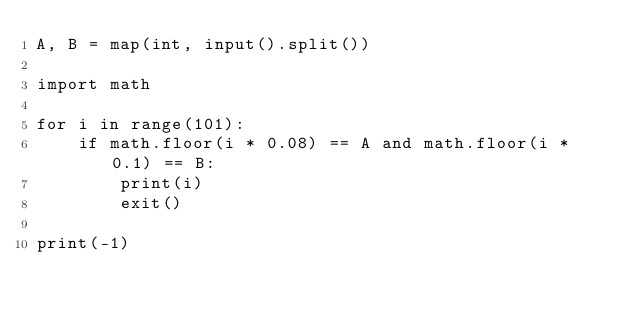Convert code to text. <code><loc_0><loc_0><loc_500><loc_500><_Python_>A, B = map(int, input().split())

import math

for i in range(101):
    if math.floor(i * 0.08) == A and math.floor(i * 0.1) == B:
        print(i)
        exit()

print(-1)
</code> 